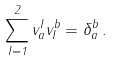<formula> <loc_0><loc_0><loc_500><loc_500>\sum _ { I = 1 } ^ { 2 } v _ { a } ^ { I } v _ { I } ^ { b } = \delta _ { a } ^ { b } \, .</formula> 